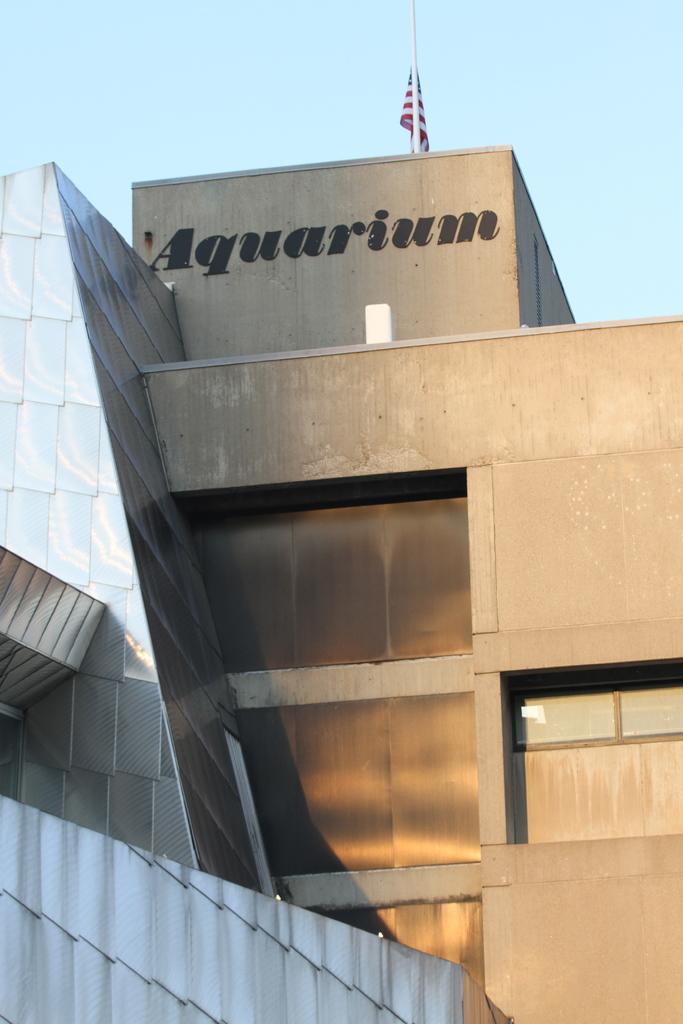What is inside this buildling?
Keep it short and to the point. Aquarium. 